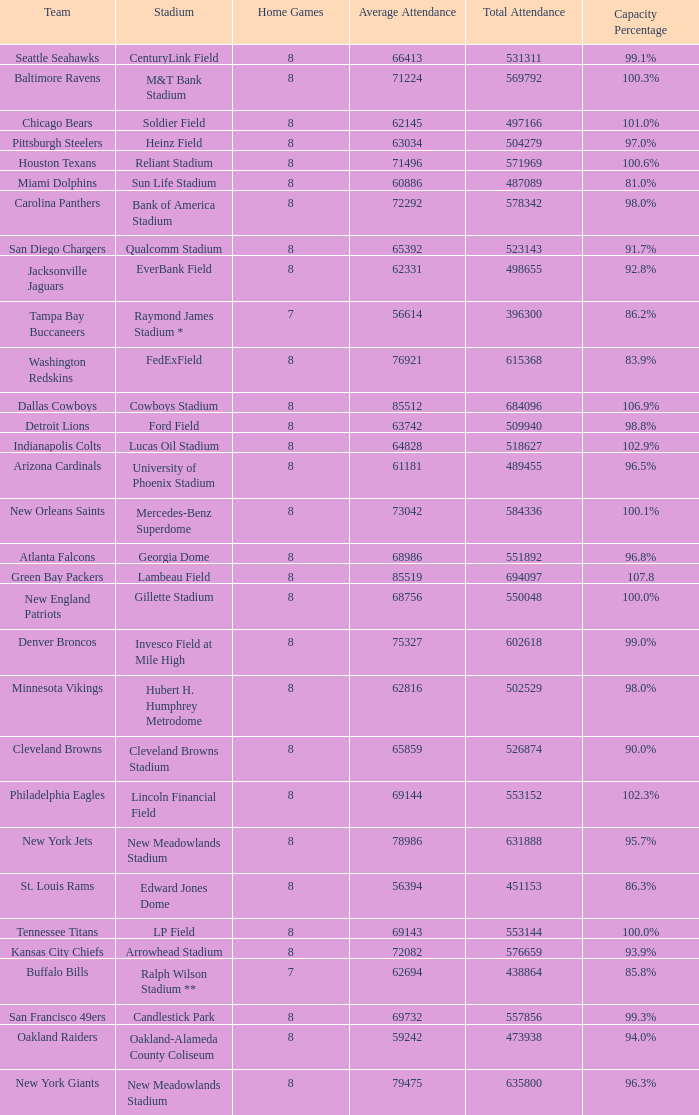What is the capacity percentage when the total attendance is 509940? 98.8%. 